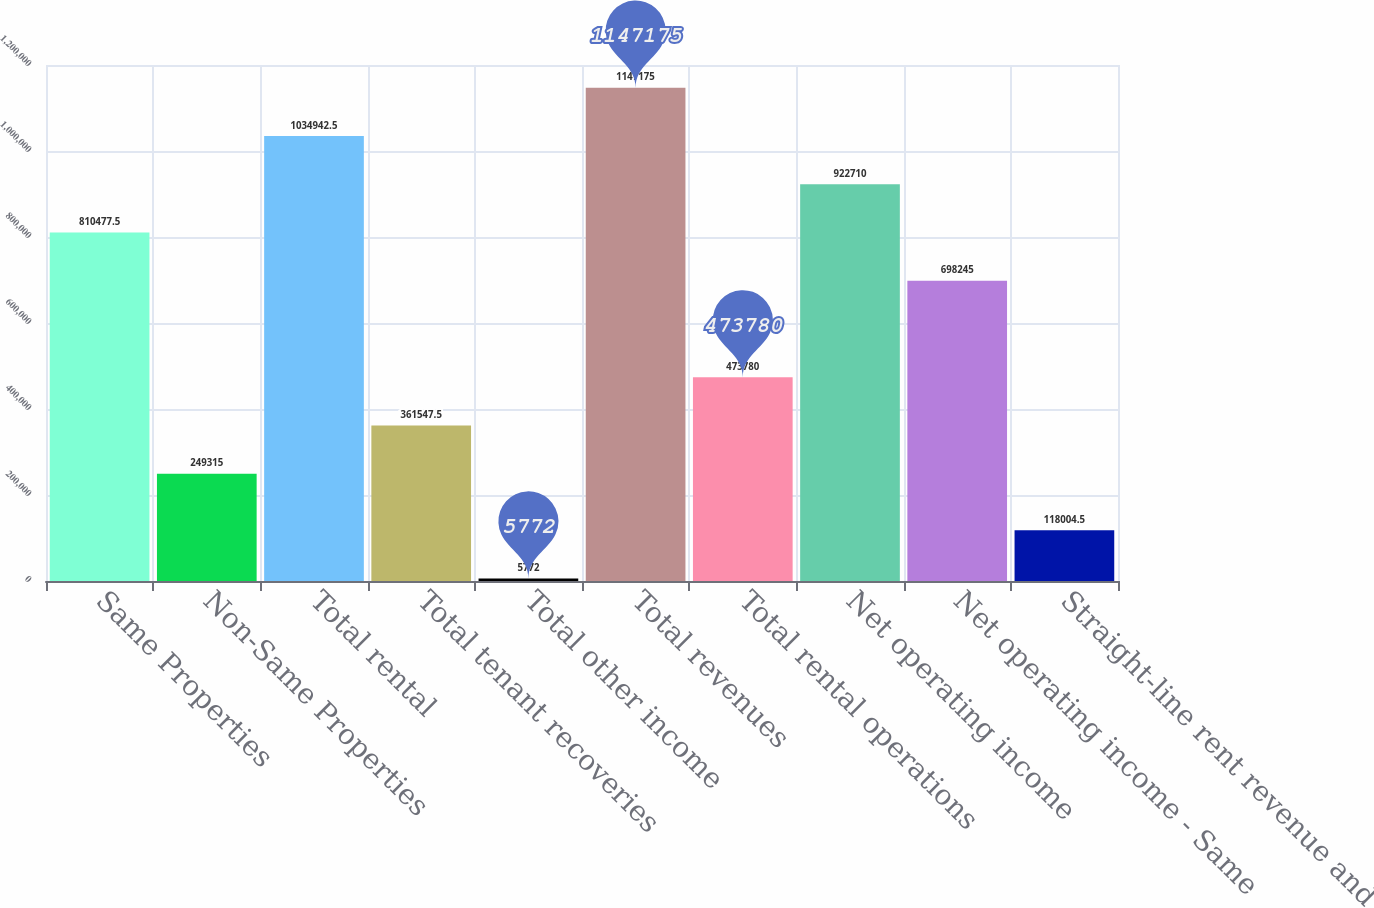<chart> <loc_0><loc_0><loc_500><loc_500><bar_chart><fcel>Same Properties<fcel>Non-Same Properties<fcel>Total rental<fcel>Total tenant recoveries<fcel>Total other income<fcel>Total revenues<fcel>Total rental operations<fcel>Net operating income<fcel>Net operating income - Same<fcel>Straight-line rent revenue and<nl><fcel>810478<fcel>249315<fcel>1.03494e+06<fcel>361548<fcel>5772<fcel>1.14718e+06<fcel>473780<fcel>922710<fcel>698245<fcel>118004<nl></chart> 